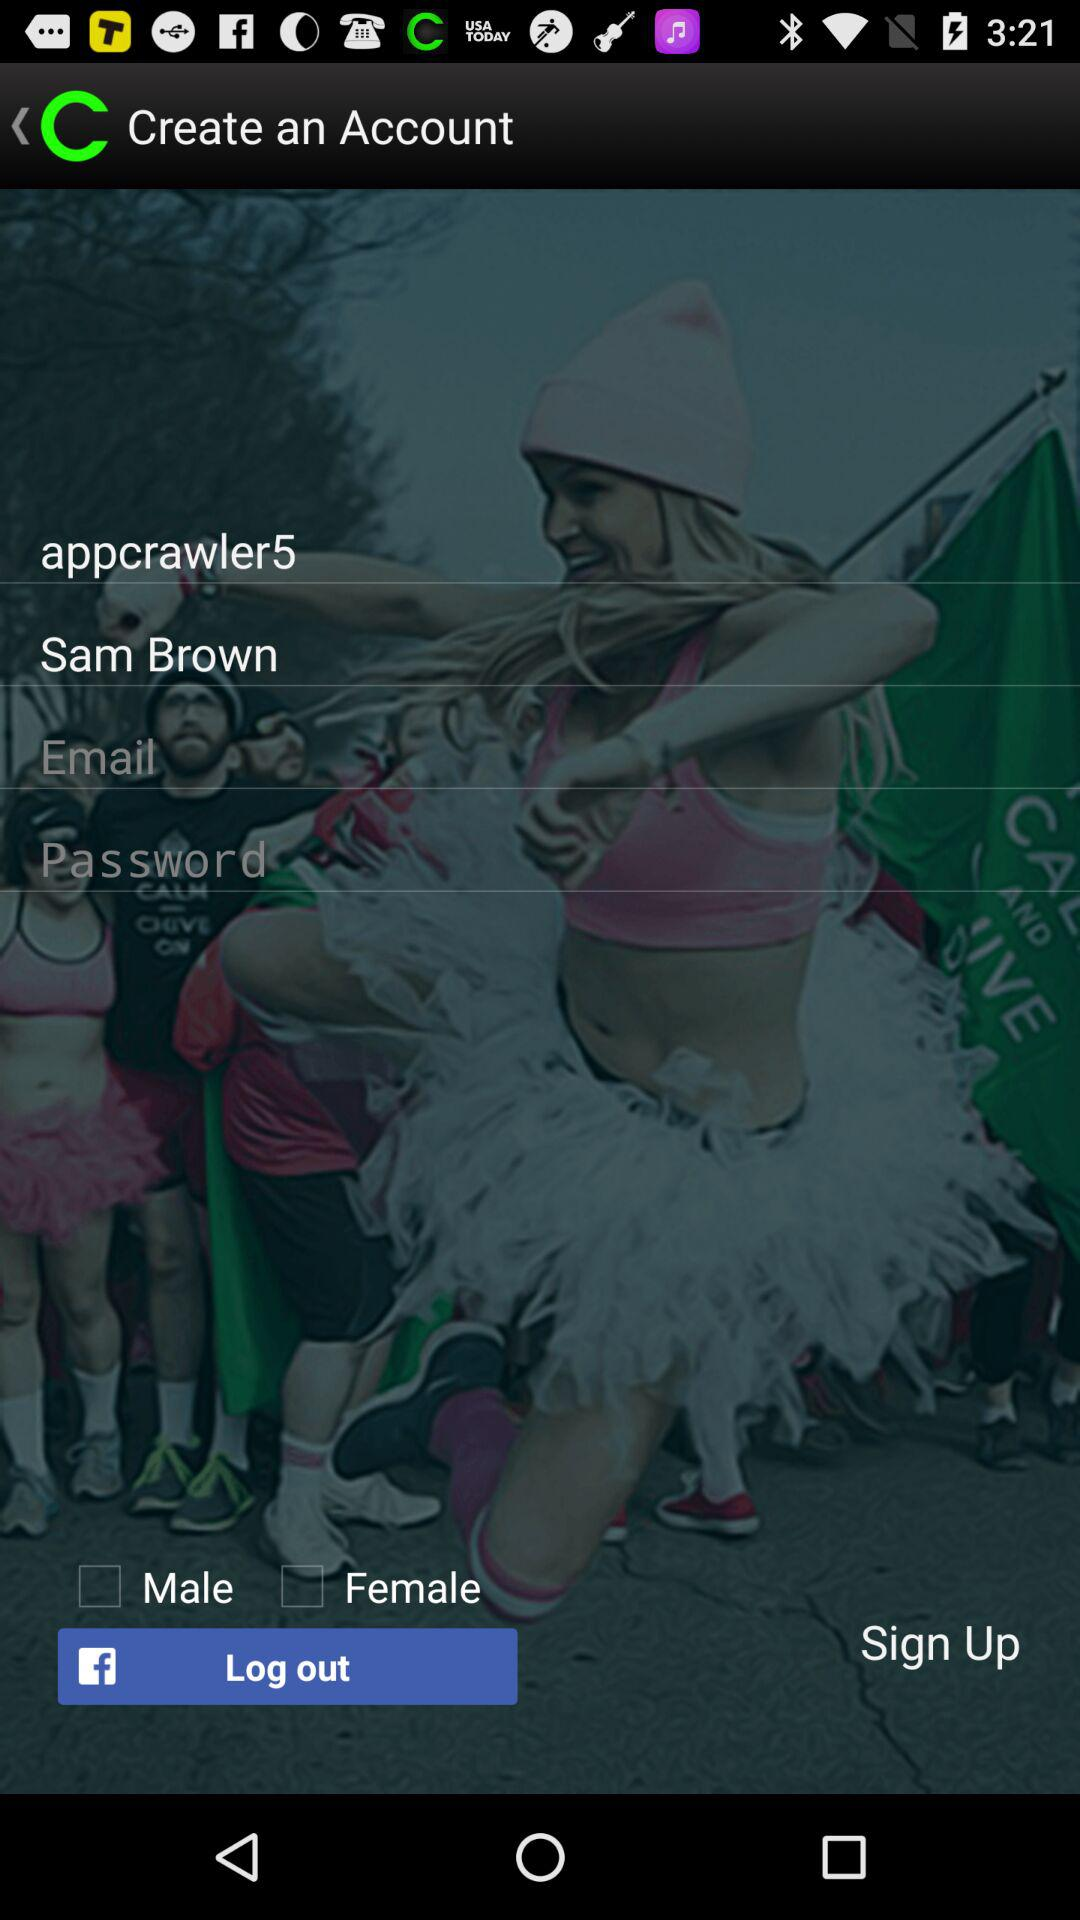What is the username? The username is "appcrawler5". 